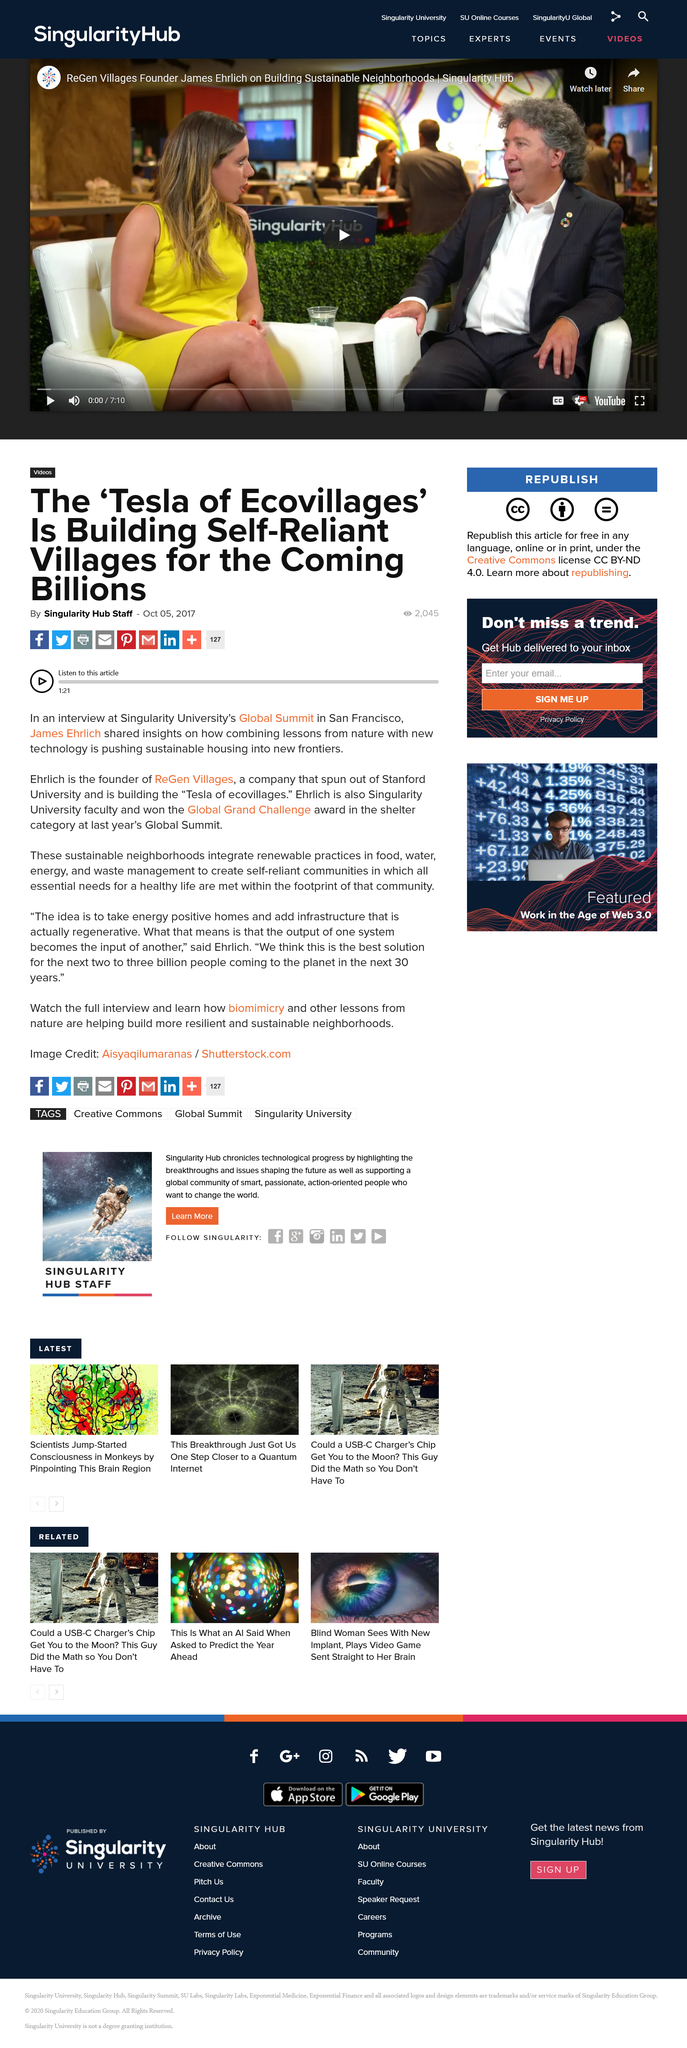Highlight a few significant elements in this photo. Ehrlich won the Global Grand Challenge at the Global Summit. James Ehrlich is the founder of ReGen Villages, and he is well-known for his innovative approach to sustainable and responsible living. The location of Singularity University's Global Summit is San Francisco. 